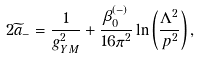<formula> <loc_0><loc_0><loc_500><loc_500>2 { \widetilde { a } } _ { - } = { \frac { 1 } { g _ { Y M } ^ { 2 } } } + { \frac { \beta _ { 0 } ^ { ( - ) } } { 1 6 \pi ^ { 2 } } } \ln \left ( { \frac { \Lambda ^ { 2 } } { p ^ { 2 } } } \right ) ,</formula> 